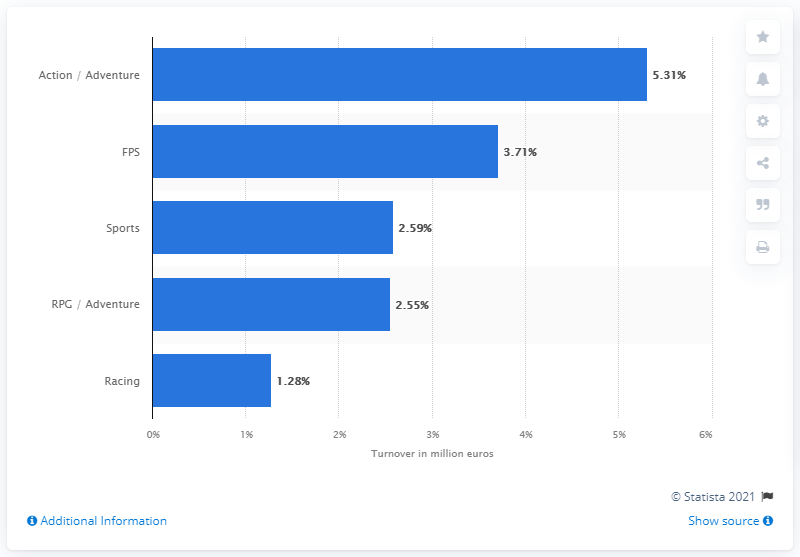Point out several critical features in this image. In 2015, the turnover of sports games was 2.59 billion dollars. 